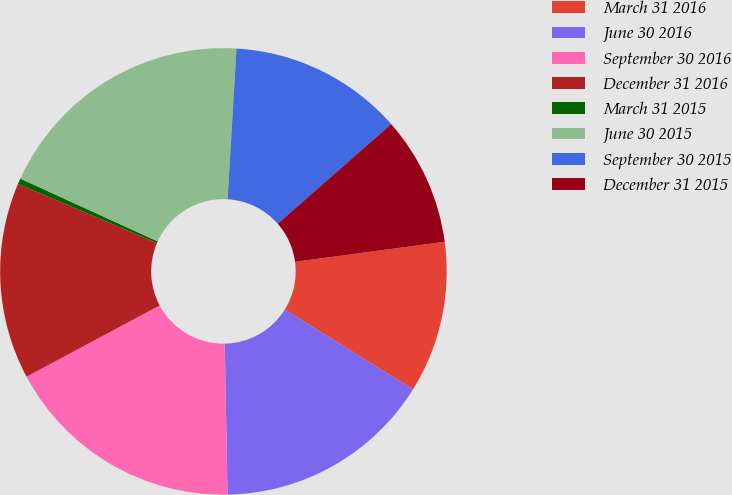Convert chart to OTSL. <chart><loc_0><loc_0><loc_500><loc_500><pie_chart><fcel>March 31 2016<fcel>June 30 2016<fcel>September 30 2016<fcel>December 31 2016<fcel>March 31 2015<fcel>June 30 2015<fcel>September 30 2015<fcel>December 31 2015<nl><fcel>10.98%<fcel>15.85%<fcel>17.48%<fcel>14.23%<fcel>0.41%<fcel>19.11%<fcel>12.6%<fcel>9.35%<nl></chart> 